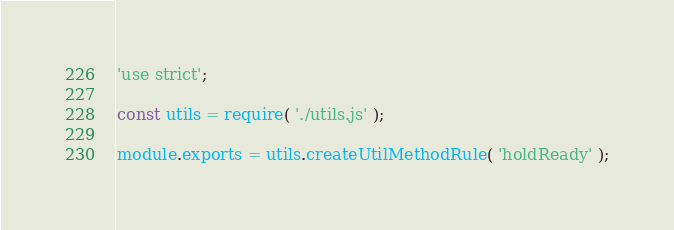<code> <loc_0><loc_0><loc_500><loc_500><_JavaScript_>'use strict';

const utils = require( './utils.js' );

module.exports = utils.createUtilMethodRule( 'holdReady' );
</code> 